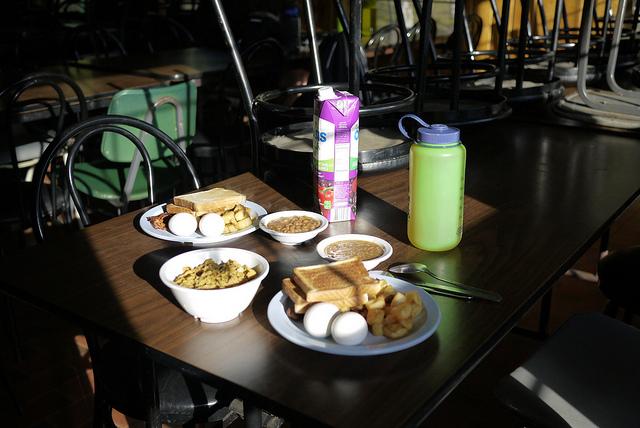How many bowls are on the table?
Concise answer only. 3. How many eggs per plate?
Give a very brief answer. 2. Is that a water bottle?
Be succinct. Yes. What mealtime does this represent?
Give a very brief answer. Breakfast. Was this picture taken at a picnic?
Answer briefly. No. 